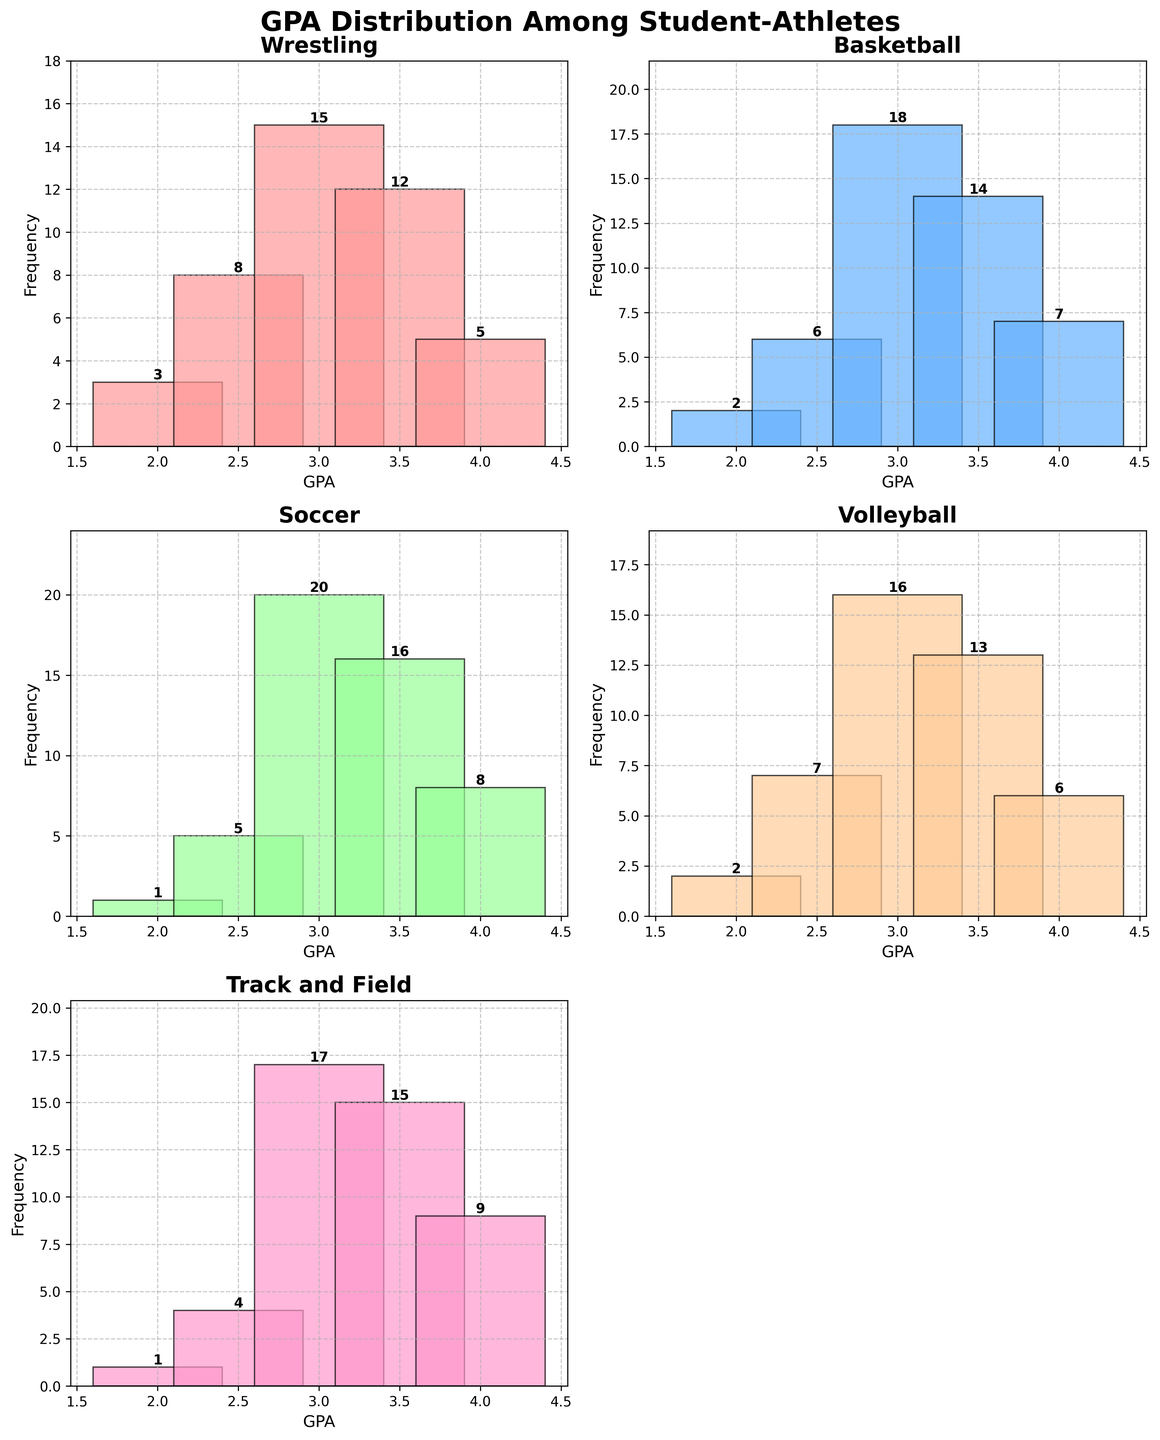What's the title of the figure? The title is located at the top of the figure and generally provides an overview of what the figure represents. In this case, the title is "GPA Distribution Among Student-Athletes."
Answer: GPA Distribution Among Student-Athletes Which sport has the highest frequency for a 3.0 GPA? By looking at the bar representing a GPA of 3.0 in each subplot, we see that Basketball has the highest bar for 3.0 GPA with a frequency of 18.
Answer: Basketball How many sports are represented in the figure? Each subplot represents a different sport, and there are 5 subplots for the sports: Wrestling, Basketball, Soccer, Volleyball, and Track and Field. One subplot is empty and not considered.
Answer: 5 Which sport has the most even GPA distribution? By examining the height of the bars in each subplot, the sport with the least variation in bar heights would have the most even distribution. In this case, Track and Field has relatively even frequencies across GPAs.
Answer: Track and Field Which sport has the highest total frequency sum for GPAs of 3.5 and above? We need to add the frequencies for 3.5 and 4.0 GPAs in each sport:
- Wrestling: 12 + 5 = 17
- Basketball: 14 + 7 = 21
- Soccer: 16 + 8 = 24
- Volleyball: 13 + 6 = 19
- Track and Field: 15 + 9 = 24
Track and Field and Soccer both have the highest sum with 24.
Answer: Soccer and Track and Field What is the most common GPA among Volleyball players? By looking at the tallest bar in the Volleyball subplot, we see that a GPA of 3.0 has the highest frequency (16).
Answer: 3.0 How does the frequency of a 4.0 GPA in Soccer compare to Wrestling? In Soccer, the frequency for a 4.0 GPA is 8, while in Wrestling it is 5. Since 8 is greater than 5, the frequency is higher in Soccer.
Answer: Soccer How many sports have a frequency of 2.5 GPA greater than 5? We look at the 2.5 GPA bar in each subplot and count those with frequency greater than 5:
- Wrestling: 8
- Basketball: 6
- Soccer: 5 (not greater, so we exclude)
- Volleyball: 7
- Track and Field: 4 (not greater, so we exclude)
There are 3 sports with a frequency greater than 5 for a 2.5 GPA.
Answer: 3 Which sport has the least frequency for a 2.0 GPA? By finding the shortest bar for a 2.0 GPA across all subplots:
- Wrestling: 3
- Basketball: 2
- Soccer: 1
- Volleyball: 2
- Track and Field: 1
Both Soccer and Track and Field have the least frequency with 1.
Answer: Soccer and Track and Field What's the difference in frequency between a 3.0 GPA and a 3.5 GPA in Basketball? The frequency for a 3.0 GPA in Basketball is 18 and for a 3.5 GPA is 14. The difference is calculated as:
18 - 14 = 4
Answer: 4 